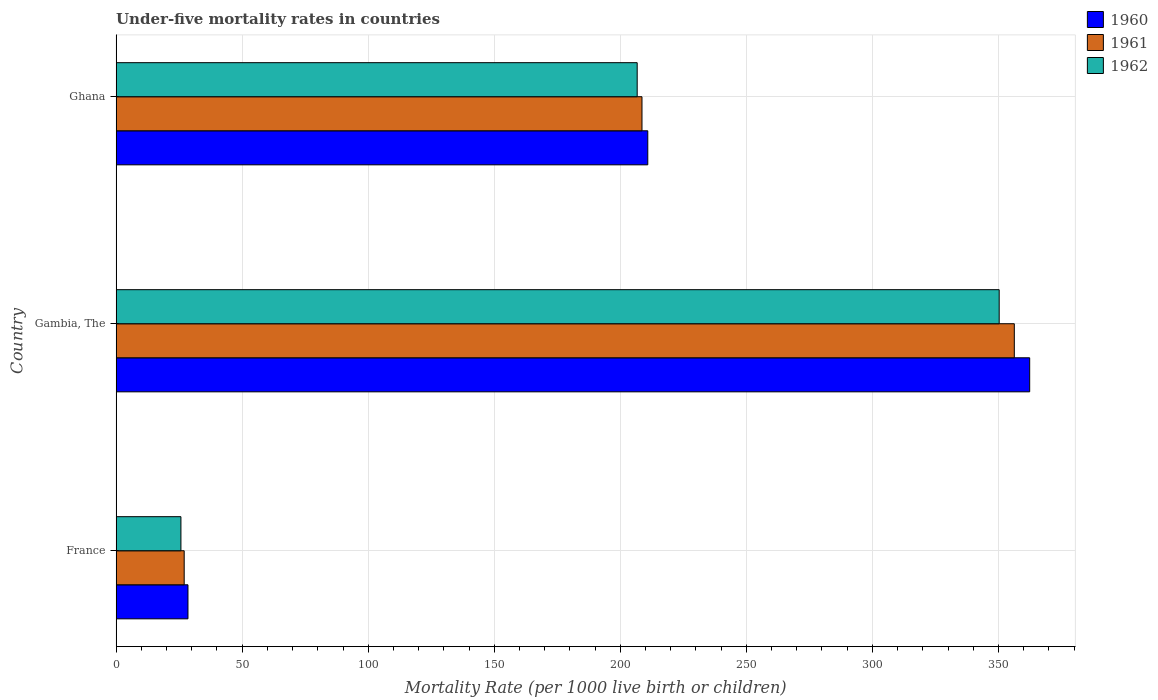How many groups of bars are there?
Your answer should be compact. 3. Are the number of bars per tick equal to the number of legend labels?
Your answer should be very brief. Yes. How many bars are there on the 2nd tick from the bottom?
Your response must be concise. 3. What is the label of the 2nd group of bars from the top?
Your answer should be very brief. Gambia, The. What is the under-five mortality rate in 1961 in Ghana?
Your answer should be very brief. 208.6. Across all countries, what is the maximum under-five mortality rate in 1960?
Offer a terse response. 362.4. Across all countries, what is the minimum under-five mortality rate in 1962?
Offer a terse response. 25.7. In which country was the under-five mortality rate in 1962 maximum?
Ensure brevity in your answer.  Gambia, The. What is the total under-five mortality rate in 1961 in the graph?
Make the answer very short. 591.9. What is the difference between the under-five mortality rate in 1962 in France and that in Gambia, The?
Ensure brevity in your answer.  -324.6. What is the difference between the under-five mortality rate in 1961 in Gambia, The and the under-five mortality rate in 1960 in France?
Offer a terse response. 327.8. What is the average under-five mortality rate in 1960 per country?
Make the answer very short. 200.6. What is the difference between the under-five mortality rate in 1960 and under-five mortality rate in 1961 in Gambia, The?
Offer a very short reply. 6.1. In how many countries, is the under-five mortality rate in 1960 greater than 170 ?
Provide a succinct answer. 2. What is the ratio of the under-five mortality rate in 1962 in France to that in Ghana?
Make the answer very short. 0.12. Is the under-five mortality rate in 1960 in Gambia, The less than that in Ghana?
Provide a short and direct response. No. What is the difference between the highest and the second highest under-five mortality rate in 1961?
Your answer should be very brief. 147.7. What is the difference between the highest and the lowest under-five mortality rate in 1960?
Your answer should be very brief. 333.9. Is the sum of the under-five mortality rate in 1961 in France and Gambia, The greater than the maximum under-five mortality rate in 1960 across all countries?
Give a very brief answer. Yes. What does the 2nd bar from the top in Ghana represents?
Keep it short and to the point. 1961. Are all the bars in the graph horizontal?
Offer a very short reply. Yes. What is the difference between two consecutive major ticks on the X-axis?
Offer a terse response. 50. Does the graph contain grids?
Offer a very short reply. Yes. Where does the legend appear in the graph?
Give a very brief answer. Top right. How many legend labels are there?
Ensure brevity in your answer.  3. What is the title of the graph?
Your response must be concise. Under-five mortality rates in countries. What is the label or title of the X-axis?
Ensure brevity in your answer.  Mortality Rate (per 1000 live birth or children). What is the Mortality Rate (per 1000 live birth or children) of 1961 in France?
Offer a terse response. 27. What is the Mortality Rate (per 1000 live birth or children) of 1962 in France?
Your answer should be compact. 25.7. What is the Mortality Rate (per 1000 live birth or children) of 1960 in Gambia, The?
Give a very brief answer. 362.4. What is the Mortality Rate (per 1000 live birth or children) in 1961 in Gambia, The?
Keep it short and to the point. 356.3. What is the Mortality Rate (per 1000 live birth or children) of 1962 in Gambia, The?
Offer a terse response. 350.3. What is the Mortality Rate (per 1000 live birth or children) of 1960 in Ghana?
Your answer should be compact. 210.9. What is the Mortality Rate (per 1000 live birth or children) in 1961 in Ghana?
Keep it short and to the point. 208.6. What is the Mortality Rate (per 1000 live birth or children) of 1962 in Ghana?
Keep it short and to the point. 206.7. Across all countries, what is the maximum Mortality Rate (per 1000 live birth or children) in 1960?
Ensure brevity in your answer.  362.4. Across all countries, what is the maximum Mortality Rate (per 1000 live birth or children) of 1961?
Give a very brief answer. 356.3. Across all countries, what is the maximum Mortality Rate (per 1000 live birth or children) of 1962?
Make the answer very short. 350.3. Across all countries, what is the minimum Mortality Rate (per 1000 live birth or children) of 1962?
Your answer should be very brief. 25.7. What is the total Mortality Rate (per 1000 live birth or children) in 1960 in the graph?
Your answer should be very brief. 601.8. What is the total Mortality Rate (per 1000 live birth or children) in 1961 in the graph?
Ensure brevity in your answer.  591.9. What is the total Mortality Rate (per 1000 live birth or children) in 1962 in the graph?
Offer a terse response. 582.7. What is the difference between the Mortality Rate (per 1000 live birth or children) in 1960 in France and that in Gambia, The?
Give a very brief answer. -333.9. What is the difference between the Mortality Rate (per 1000 live birth or children) in 1961 in France and that in Gambia, The?
Offer a terse response. -329.3. What is the difference between the Mortality Rate (per 1000 live birth or children) in 1962 in France and that in Gambia, The?
Provide a short and direct response. -324.6. What is the difference between the Mortality Rate (per 1000 live birth or children) in 1960 in France and that in Ghana?
Your response must be concise. -182.4. What is the difference between the Mortality Rate (per 1000 live birth or children) in 1961 in France and that in Ghana?
Your answer should be compact. -181.6. What is the difference between the Mortality Rate (per 1000 live birth or children) of 1962 in France and that in Ghana?
Ensure brevity in your answer.  -181. What is the difference between the Mortality Rate (per 1000 live birth or children) of 1960 in Gambia, The and that in Ghana?
Your answer should be very brief. 151.5. What is the difference between the Mortality Rate (per 1000 live birth or children) in 1961 in Gambia, The and that in Ghana?
Provide a succinct answer. 147.7. What is the difference between the Mortality Rate (per 1000 live birth or children) in 1962 in Gambia, The and that in Ghana?
Offer a very short reply. 143.6. What is the difference between the Mortality Rate (per 1000 live birth or children) in 1960 in France and the Mortality Rate (per 1000 live birth or children) in 1961 in Gambia, The?
Your response must be concise. -327.8. What is the difference between the Mortality Rate (per 1000 live birth or children) in 1960 in France and the Mortality Rate (per 1000 live birth or children) in 1962 in Gambia, The?
Keep it short and to the point. -321.8. What is the difference between the Mortality Rate (per 1000 live birth or children) in 1961 in France and the Mortality Rate (per 1000 live birth or children) in 1962 in Gambia, The?
Your response must be concise. -323.3. What is the difference between the Mortality Rate (per 1000 live birth or children) in 1960 in France and the Mortality Rate (per 1000 live birth or children) in 1961 in Ghana?
Make the answer very short. -180.1. What is the difference between the Mortality Rate (per 1000 live birth or children) of 1960 in France and the Mortality Rate (per 1000 live birth or children) of 1962 in Ghana?
Your answer should be compact. -178.2. What is the difference between the Mortality Rate (per 1000 live birth or children) of 1961 in France and the Mortality Rate (per 1000 live birth or children) of 1962 in Ghana?
Give a very brief answer. -179.7. What is the difference between the Mortality Rate (per 1000 live birth or children) of 1960 in Gambia, The and the Mortality Rate (per 1000 live birth or children) of 1961 in Ghana?
Make the answer very short. 153.8. What is the difference between the Mortality Rate (per 1000 live birth or children) of 1960 in Gambia, The and the Mortality Rate (per 1000 live birth or children) of 1962 in Ghana?
Your answer should be compact. 155.7. What is the difference between the Mortality Rate (per 1000 live birth or children) of 1961 in Gambia, The and the Mortality Rate (per 1000 live birth or children) of 1962 in Ghana?
Offer a terse response. 149.6. What is the average Mortality Rate (per 1000 live birth or children) in 1960 per country?
Make the answer very short. 200.6. What is the average Mortality Rate (per 1000 live birth or children) of 1961 per country?
Keep it short and to the point. 197.3. What is the average Mortality Rate (per 1000 live birth or children) of 1962 per country?
Your answer should be compact. 194.23. What is the difference between the Mortality Rate (per 1000 live birth or children) of 1961 and Mortality Rate (per 1000 live birth or children) of 1962 in France?
Offer a very short reply. 1.3. What is the difference between the Mortality Rate (per 1000 live birth or children) in 1960 and Mortality Rate (per 1000 live birth or children) in 1961 in Gambia, The?
Your answer should be compact. 6.1. What is the difference between the Mortality Rate (per 1000 live birth or children) of 1960 and Mortality Rate (per 1000 live birth or children) of 1962 in Gambia, The?
Provide a short and direct response. 12.1. What is the difference between the Mortality Rate (per 1000 live birth or children) of 1960 and Mortality Rate (per 1000 live birth or children) of 1961 in Ghana?
Your answer should be compact. 2.3. What is the difference between the Mortality Rate (per 1000 live birth or children) of 1961 and Mortality Rate (per 1000 live birth or children) of 1962 in Ghana?
Provide a succinct answer. 1.9. What is the ratio of the Mortality Rate (per 1000 live birth or children) in 1960 in France to that in Gambia, The?
Offer a terse response. 0.08. What is the ratio of the Mortality Rate (per 1000 live birth or children) in 1961 in France to that in Gambia, The?
Your answer should be very brief. 0.08. What is the ratio of the Mortality Rate (per 1000 live birth or children) in 1962 in France to that in Gambia, The?
Keep it short and to the point. 0.07. What is the ratio of the Mortality Rate (per 1000 live birth or children) in 1960 in France to that in Ghana?
Your response must be concise. 0.14. What is the ratio of the Mortality Rate (per 1000 live birth or children) in 1961 in France to that in Ghana?
Keep it short and to the point. 0.13. What is the ratio of the Mortality Rate (per 1000 live birth or children) of 1962 in France to that in Ghana?
Provide a succinct answer. 0.12. What is the ratio of the Mortality Rate (per 1000 live birth or children) of 1960 in Gambia, The to that in Ghana?
Your response must be concise. 1.72. What is the ratio of the Mortality Rate (per 1000 live birth or children) in 1961 in Gambia, The to that in Ghana?
Offer a terse response. 1.71. What is the ratio of the Mortality Rate (per 1000 live birth or children) in 1962 in Gambia, The to that in Ghana?
Keep it short and to the point. 1.69. What is the difference between the highest and the second highest Mortality Rate (per 1000 live birth or children) of 1960?
Make the answer very short. 151.5. What is the difference between the highest and the second highest Mortality Rate (per 1000 live birth or children) in 1961?
Offer a very short reply. 147.7. What is the difference between the highest and the second highest Mortality Rate (per 1000 live birth or children) in 1962?
Provide a short and direct response. 143.6. What is the difference between the highest and the lowest Mortality Rate (per 1000 live birth or children) of 1960?
Keep it short and to the point. 333.9. What is the difference between the highest and the lowest Mortality Rate (per 1000 live birth or children) of 1961?
Your response must be concise. 329.3. What is the difference between the highest and the lowest Mortality Rate (per 1000 live birth or children) in 1962?
Keep it short and to the point. 324.6. 